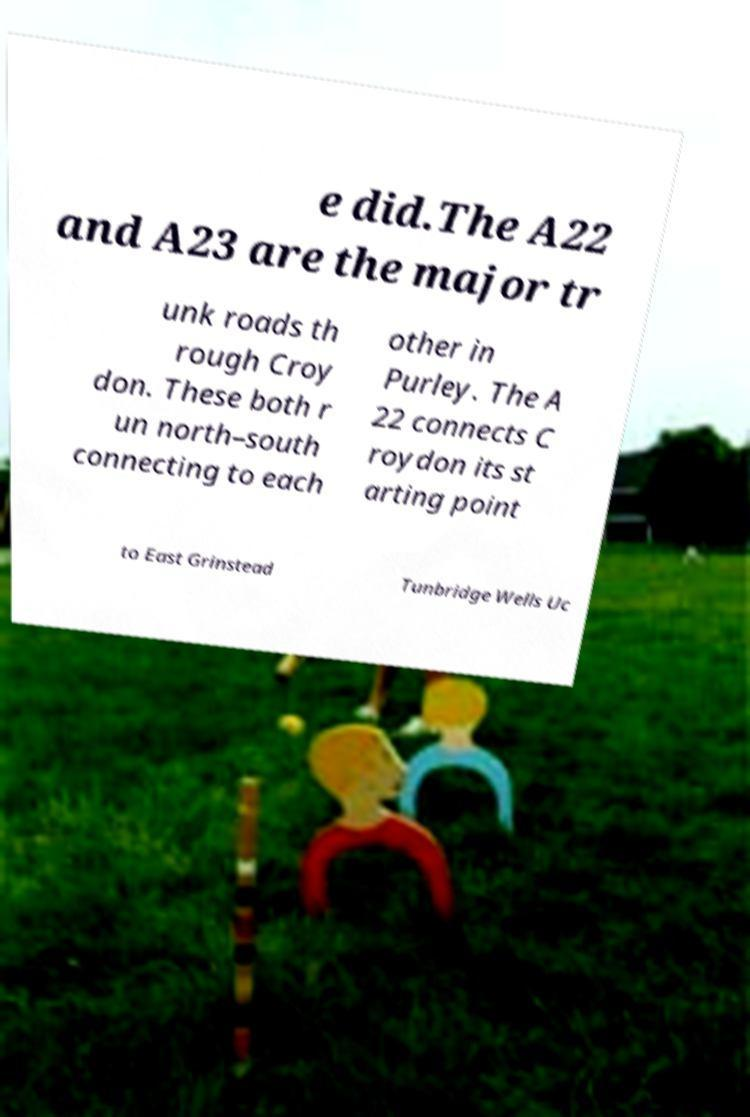Can you read and provide the text displayed in the image?This photo seems to have some interesting text. Can you extract and type it out for me? e did.The A22 and A23 are the major tr unk roads th rough Croy don. These both r un north–south connecting to each other in Purley. The A 22 connects C roydon its st arting point to East Grinstead Tunbridge Wells Uc 